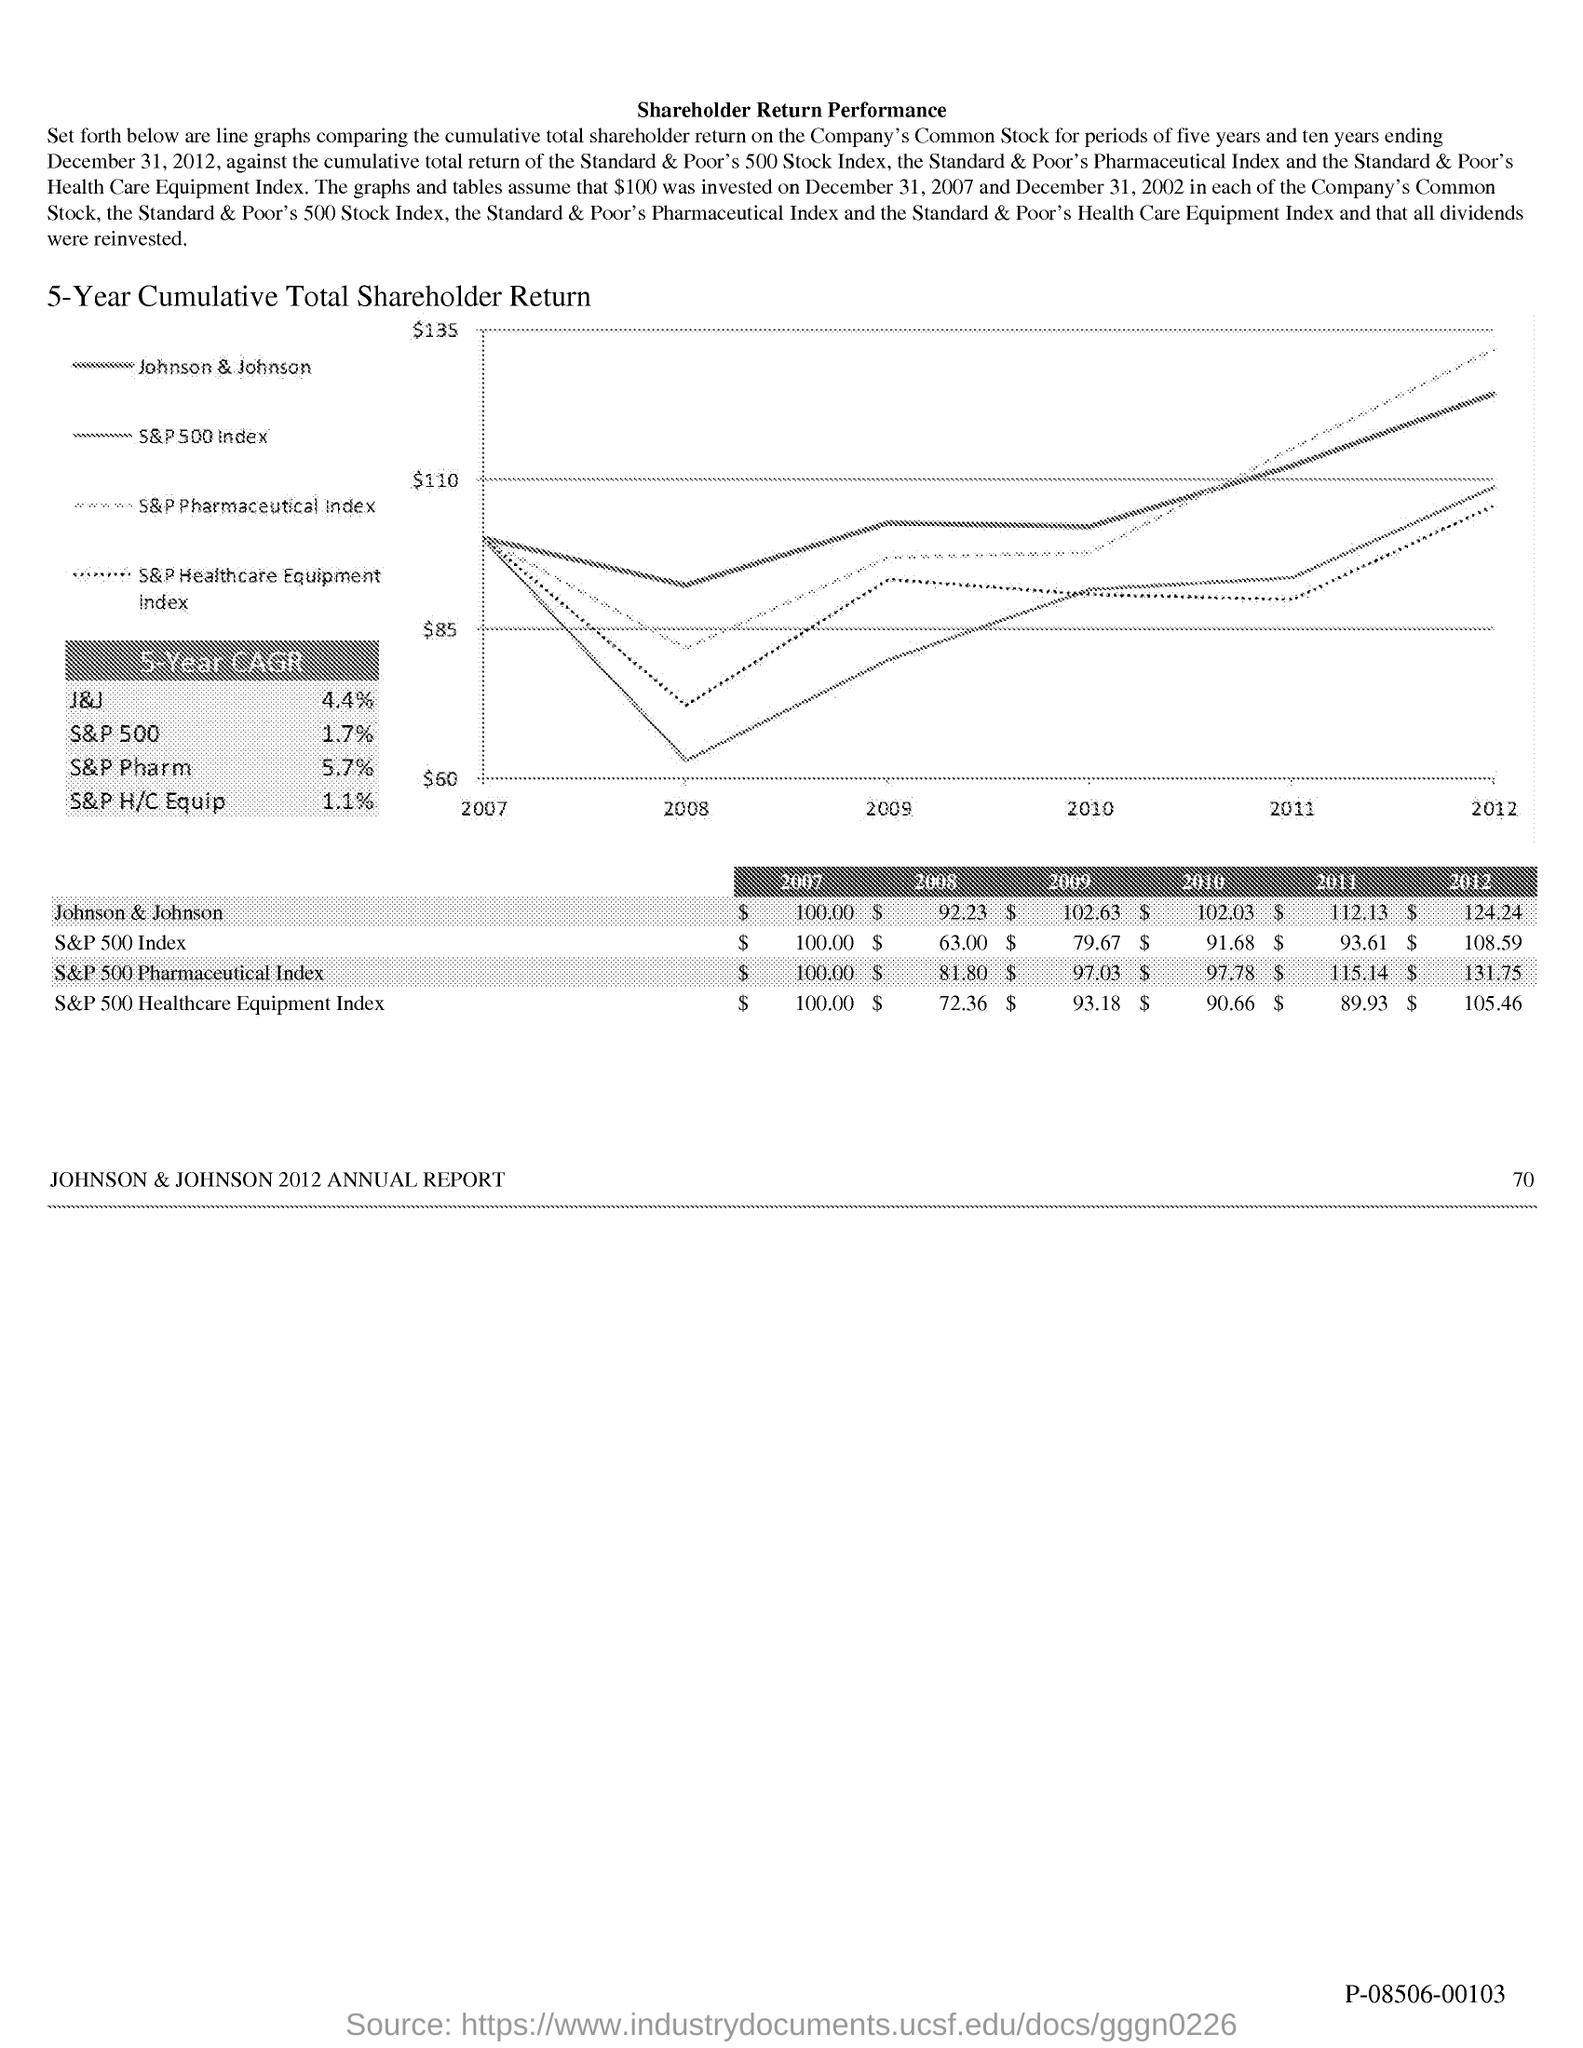What is the value of johnson & johnson in 2008?
Provide a short and direct response. $ 92.23. What is the value of johnson & johnson in 2009?
Your response must be concise. $102.63. What is the value of johnson & johnson in 2010?
Your response must be concise. $ 102.03. What is the value of johnson & johnson in 2011?
Ensure brevity in your answer.  $ 112.13. What is the value of johnson & johnson in 2012?
Give a very brief answer. $124.24. What is the value of s&p 500 index in 2007?
Offer a terse response. $100.00. What is the value of s&p 500 index in 2008?
Keep it short and to the point. $63.00. What is the value of s&p 500 index in 2009?
Give a very brief answer. $79.67. What is the value of s&p 500 index in 2010 ?
Give a very brief answer. $ 91.68. 